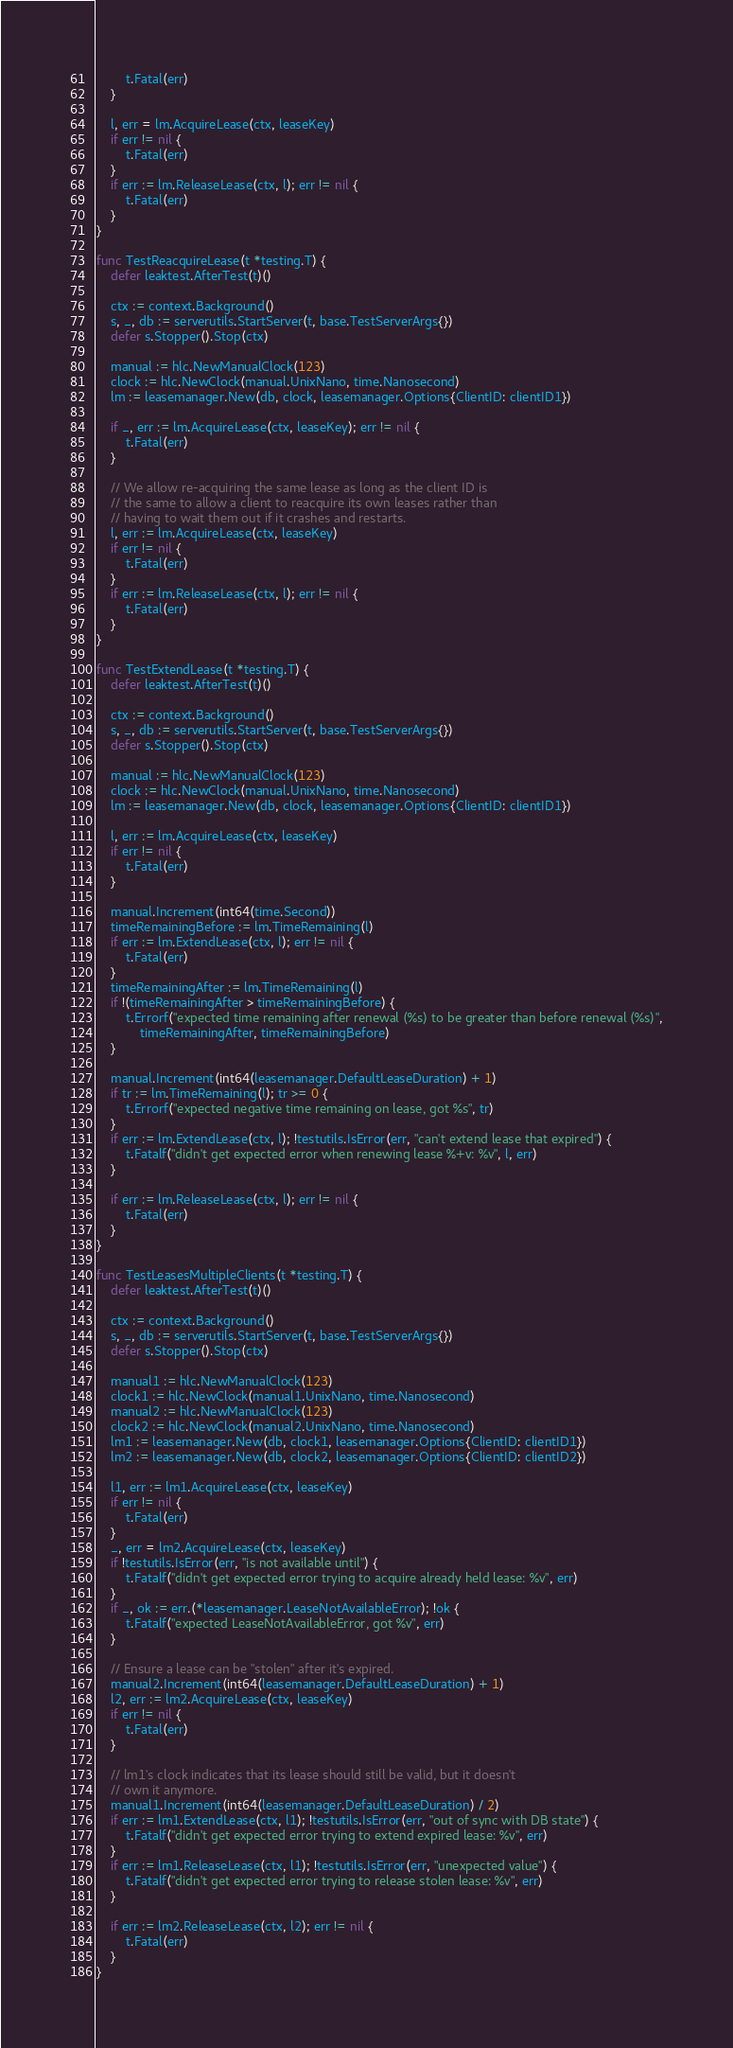Convert code to text. <code><loc_0><loc_0><loc_500><loc_500><_Go_>		t.Fatal(err)
	}

	l, err = lm.AcquireLease(ctx, leaseKey)
	if err != nil {
		t.Fatal(err)
	}
	if err := lm.ReleaseLease(ctx, l); err != nil {
		t.Fatal(err)
	}
}

func TestReacquireLease(t *testing.T) {
	defer leaktest.AfterTest(t)()

	ctx := context.Background()
	s, _, db := serverutils.StartServer(t, base.TestServerArgs{})
	defer s.Stopper().Stop(ctx)

	manual := hlc.NewManualClock(123)
	clock := hlc.NewClock(manual.UnixNano, time.Nanosecond)
	lm := leasemanager.New(db, clock, leasemanager.Options{ClientID: clientID1})

	if _, err := lm.AcquireLease(ctx, leaseKey); err != nil {
		t.Fatal(err)
	}

	// We allow re-acquiring the same lease as long as the client ID is
	// the same to allow a client to reacquire its own leases rather than
	// having to wait them out if it crashes and restarts.
	l, err := lm.AcquireLease(ctx, leaseKey)
	if err != nil {
		t.Fatal(err)
	}
	if err := lm.ReleaseLease(ctx, l); err != nil {
		t.Fatal(err)
	}
}

func TestExtendLease(t *testing.T) {
	defer leaktest.AfterTest(t)()

	ctx := context.Background()
	s, _, db := serverutils.StartServer(t, base.TestServerArgs{})
	defer s.Stopper().Stop(ctx)

	manual := hlc.NewManualClock(123)
	clock := hlc.NewClock(manual.UnixNano, time.Nanosecond)
	lm := leasemanager.New(db, clock, leasemanager.Options{ClientID: clientID1})

	l, err := lm.AcquireLease(ctx, leaseKey)
	if err != nil {
		t.Fatal(err)
	}

	manual.Increment(int64(time.Second))
	timeRemainingBefore := lm.TimeRemaining(l)
	if err := lm.ExtendLease(ctx, l); err != nil {
		t.Fatal(err)
	}
	timeRemainingAfter := lm.TimeRemaining(l)
	if !(timeRemainingAfter > timeRemainingBefore) {
		t.Errorf("expected time remaining after renewal (%s) to be greater than before renewal (%s)",
			timeRemainingAfter, timeRemainingBefore)
	}

	manual.Increment(int64(leasemanager.DefaultLeaseDuration) + 1)
	if tr := lm.TimeRemaining(l); tr >= 0 {
		t.Errorf("expected negative time remaining on lease, got %s", tr)
	}
	if err := lm.ExtendLease(ctx, l); !testutils.IsError(err, "can't extend lease that expired") {
		t.Fatalf("didn't get expected error when renewing lease %+v: %v", l, err)
	}

	if err := lm.ReleaseLease(ctx, l); err != nil {
		t.Fatal(err)
	}
}

func TestLeasesMultipleClients(t *testing.T) {
	defer leaktest.AfterTest(t)()

	ctx := context.Background()
	s, _, db := serverutils.StartServer(t, base.TestServerArgs{})
	defer s.Stopper().Stop(ctx)

	manual1 := hlc.NewManualClock(123)
	clock1 := hlc.NewClock(manual1.UnixNano, time.Nanosecond)
	manual2 := hlc.NewManualClock(123)
	clock2 := hlc.NewClock(manual2.UnixNano, time.Nanosecond)
	lm1 := leasemanager.New(db, clock1, leasemanager.Options{ClientID: clientID1})
	lm2 := leasemanager.New(db, clock2, leasemanager.Options{ClientID: clientID2})

	l1, err := lm1.AcquireLease(ctx, leaseKey)
	if err != nil {
		t.Fatal(err)
	}
	_, err = lm2.AcquireLease(ctx, leaseKey)
	if !testutils.IsError(err, "is not available until") {
		t.Fatalf("didn't get expected error trying to acquire already held lease: %v", err)
	}
	if _, ok := err.(*leasemanager.LeaseNotAvailableError); !ok {
		t.Fatalf("expected LeaseNotAvailableError, got %v", err)
	}

	// Ensure a lease can be "stolen" after it's expired.
	manual2.Increment(int64(leasemanager.DefaultLeaseDuration) + 1)
	l2, err := lm2.AcquireLease(ctx, leaseKey)
	if err != nil {
		t.Fatal(err)
	}

	// lm1's clock indicates that its lease should still be valid, but it doesn't
	// own it anymore.
	manual1.Increment(int64(leasemanager.DefaultLeaseDuration) / 2)
	if err := lm1.ExtendLease(ctx, l1); !testutils.IsError(err, "out of sync with DB state") {
		t.Fatalf("didn't get expected error trying to extend expired lease: %v", err)
	}
	if err := lm1.ReleaseLease(ctx, l1); !testutils.IsError(err, "unexpected value") {
		t.Fatalf("didn't get expected error trying to release stolen lease: %v", err)
	}

	if err := lm2.ReleaseLease(ctx, l2); err != nil {
		t.Fatal(err)
	}
}
</code> 